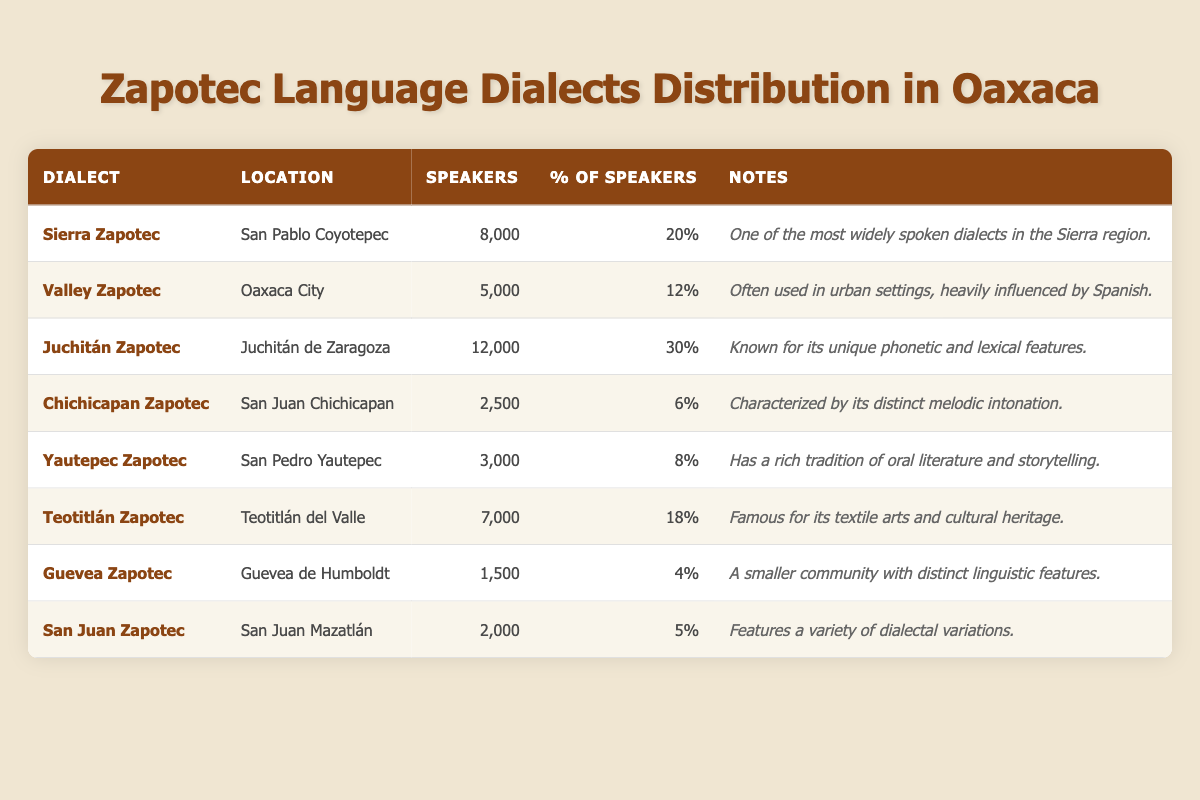What is the dialect with the highest number of speakers? From the table, Juchitán Zapotec has 12,000 speakers, which is more than any other dialect listed.
Answer: Juchitán Zapotec How many speakers does the Guevea Zapotec dialect have? According to the table, Guevea Zapotec has 1,500 speakers as stated in the corresponding row.
Answer: 1,500 Which dialect has a percentage of speakers closest to 10%? The dialect with the closest percentage of speakers to 10% is Valley Zapotec, which has 12%.
Answer: Valley Zapotec What is the total number of speakers across all Zapotec dialects listed? Adding all the speakers: 8,000 (Sierra) + 5,000 (Valley) + 12,000 (Juchitán) + 2,500 (Chichicapan) + 3,000 (Yautepec) + 7,000 (Teotitlán) + 1,500 (Guevea) + 2,000 (San Juan) = 39,000 speakers in total.
Answer: 39,000 Is the San Juan Zapotec dialect spoken by more than 2,000 people? The table lists San Juan Zapotec as having 2,000 speakers, which does not exceed that number. Therefore, the statement is false.
Answer: No What is the difference in the number of speakers between Juchitán Zapotec and Chichicapan Zapotec? Juchitán Zapotec has 12,000 speakers, and Chichicapan Zapotec has 2,500 speakers. The difference is 12,000 - 2,500 = 9,500.
Answer: 9,500 Which dialect has the least number of speakers, and what is that number? The least number of speakers is found in Guevea Zapotec, which has 1,500 speakers.
Answer: Guevea Zapotec, 1,500 Which dialect is noted for having a rich tradition of oral literature and storytelling? The Yautepec Zapotec is specifically noted in the table for its rich tradition of oral literature and storytelling.
Answer: Yautepec Zapotec How many dialects have more than 5,000 speakers? The dialects with more than 5,000 speakers are Juchitán Zapotec (12,000), Sierra Zapotec (8,000), and Teotitlán Zapotec (7,000), totaling three dialects.
Answer: 3 What percentage of speakers does the Chichicapan Zapotec dialect represent? According to the table, Chichicapan Zapotec has 6%, which is provided next to its speaker count.
Answer: 6% 